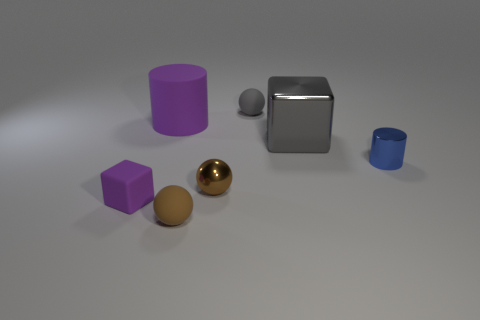Subtract all cyan cubes. How many brown spheres are left? 2 Add 1 tiny purple matte things. How many objects exist? 8 Subtract all tiny metallic spheres. How many spheres are left? 2 Subtract all cylinders. How many objects are left? 5 Subtract all purple cylinders. How many cylinders are left? 1 Subtract 0 gray cylinders. How many objects are left? 7 Subtract all blue cylinders. Subtract all green cubes. How many cylinders are left? 1 Subtract all blue things. Subtract all matte things. How many objects are left? 2 Add 2 small purple rubber objects. How many small purple rubber objects are left? 3 Add 4 gray balls. How many gray balls exist? 5 